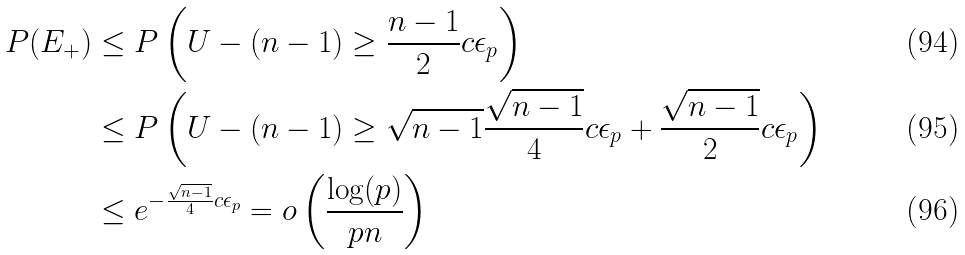<formula> <loc_0><loc_0><loc_500><loc_500>P ( E _ { + } ) & \leq P \left ( U - ( n - 1 ) \geq \frac { n - 1 } { 2 } c \epsilon _ { p } \right ) \\ & \leq P \left ( U - ( n - 1 ) \geq \sqrt { n - 1 } \frac { \sqrt { n - 1 } } { 4 } c \epsilon _ { p } + \frac { \sqrt { n - 1 } } { 2 } c \epsilon _ { p } \right ) \\ & \leq e ^ { - \frac { \sqrt { n - 1 } } { 4 } c \epsilon _ { p } } = o \left ( \frac { \log ( p ) } { p n } \right )</formula> 